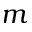<formula> <loc_0><loc_0><loc_500><loc_500>m</formula> 